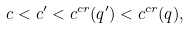Convert formula to latex. <formula><loc_0><loc_0><loc_500><loc_500>c < c ^ { \prime } < c ^ { c r } ( q ^ { \prime } ) < c ^ { c r } ( q ) ,</formula> 